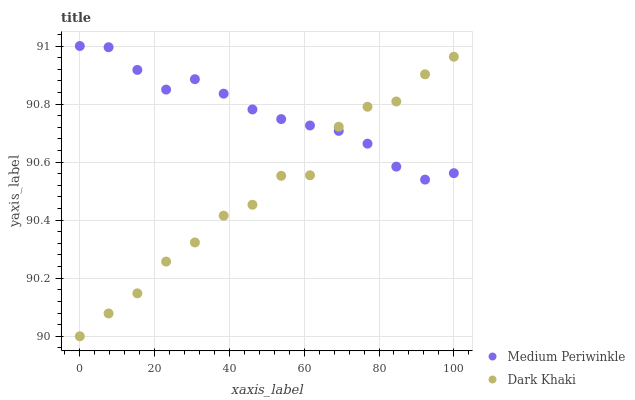Does Dark Khaki have the minimum area under the curve?
Answer yes or no. Yes. Does Medium Periwinkle have the maximum area under the curve?
Answer yes or no. Yes. Does Medium Periwinkle have the minimum area under the curve?
Answer yes or no. No. Is Medium Periwinkle the smoothest?
Answer yes or no. Yes. Is Dark Khaki the roughest?
Answer yes or no. Yes. Is Medium Periwinkle the roughest?
Answer yes or no. No. Does Dark Khaki have the lowest value?
Answer yes or no. Yes. Does Medium Periwinkle have the lowest value?
Answer yes or no. No. Does Medium Periwinkle have the highest value?
Answer yes or no. Yes. Does Medium Periwinkle intersect Dark Khaki?
Answer yes or no. Yes. Is Medium Periwinkle less than Dark Khaki?
Answer yes or no. No. Is Medium Periwinkle greater than Dark Khaki?
Answer yes or no. No. 